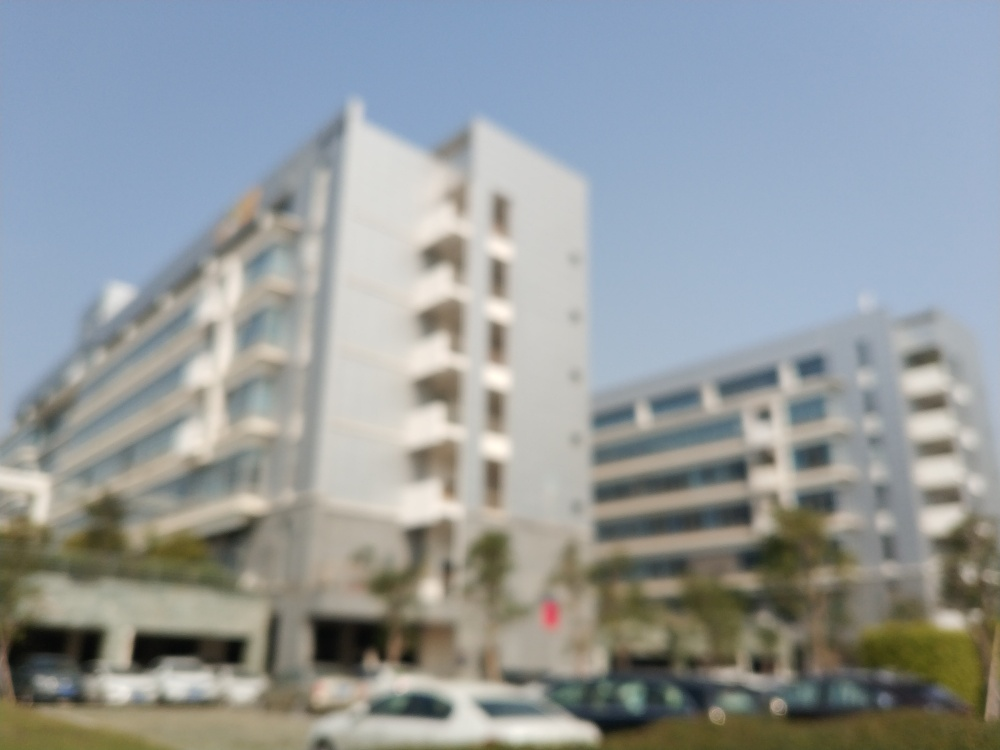What elements of the picture can indicate the location or setting of the photo? Despite the blur, the vertical lines and rectangular shapes hint at modern buildings, likely in an urban or commercial area. Also, the presence of parked cars adds to the urban setting narrative. 